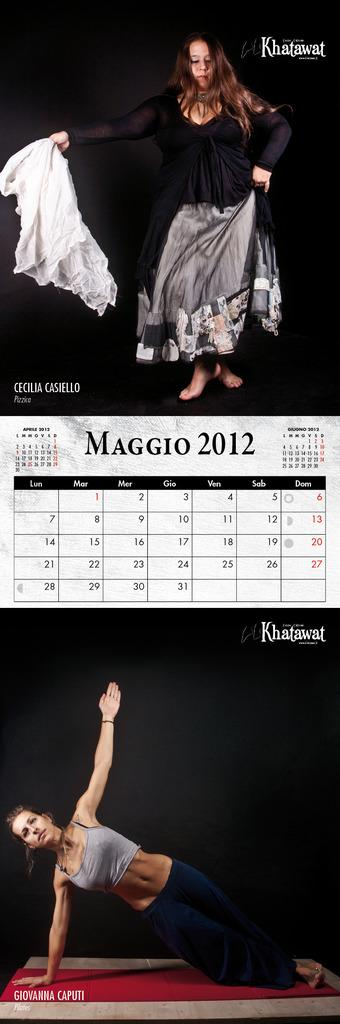What is the main object in the image? There is a calendar in the image. What can be seen on the calendar besides the dates? There are images of ladies at the top and bottom of the calendar. How would you describe the background of the images? The background of the images is dark. Are there any words or phrases on the images? Yes, there is text on the images. What type of harmony is being taught in the image? There is no indication of any educational content or teaching in the image, so it cannot be determined what type of harmony is being taught. 